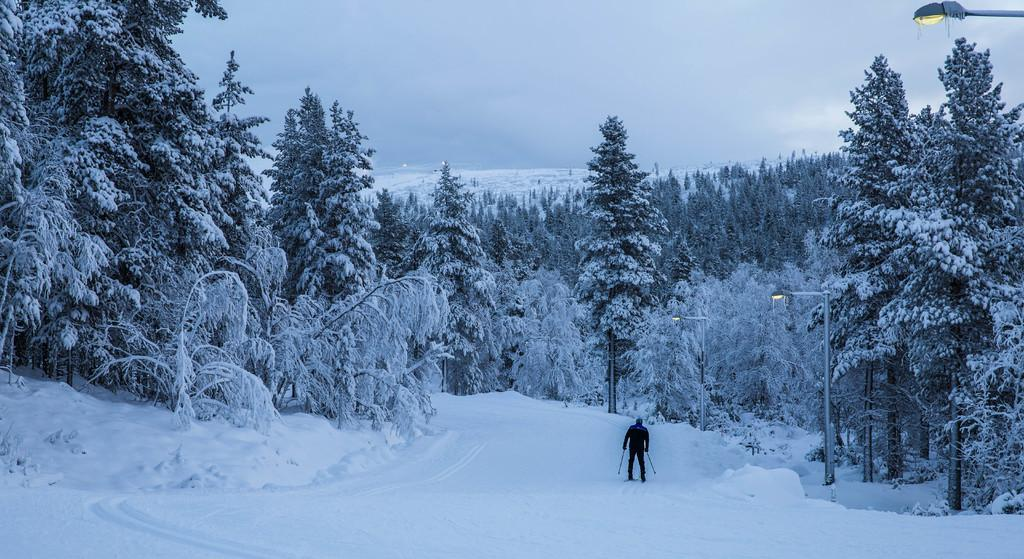What activity is the person in the image engaged in? The person is skiing in the image. On what surface is the person skiing? The person is skiing on snow. What type of vegetation can be seen in the image? There are trees in the image. What is the condition of the trees in the image? The trees are covered with snow. What type of artificial lighting is present in the image? There are street lights in the image. What is visible at the top of the image? The sky is visible at the top of the image. How does the person compare their skiing skills to a banana in the image? There is no banana present in the image, and therefore no comparison can be made. 